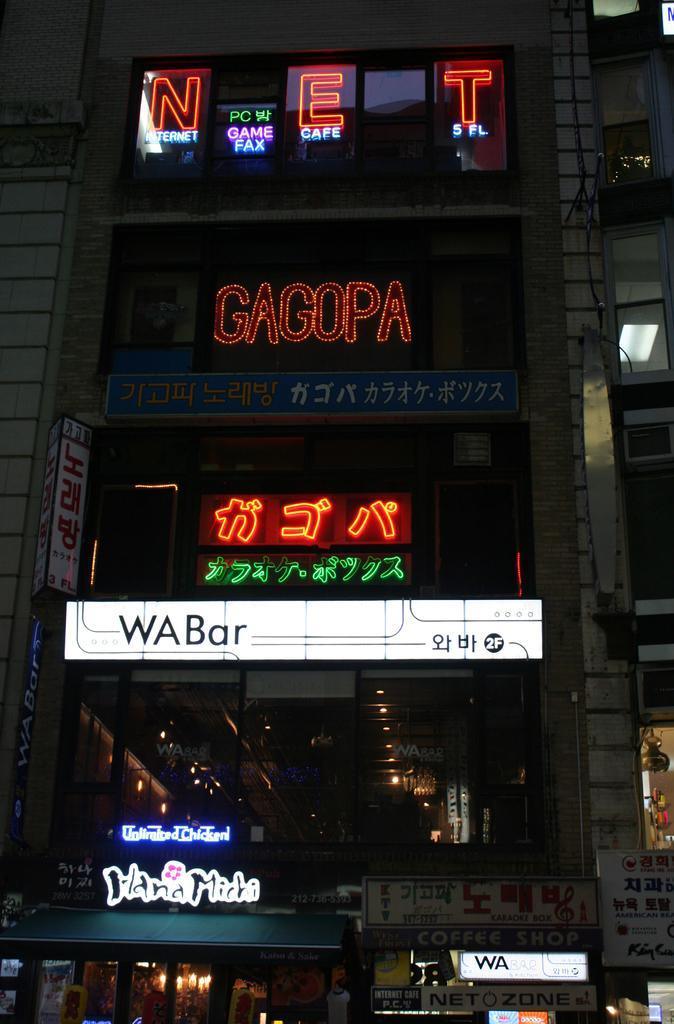Describe this image in one or two sentences. In this image there is a building truncated, there are boards on the building, there is text on the boards, there is a board truncated towards the right of the image, there is a light, there is a board truncated towards the bottom of the image. 